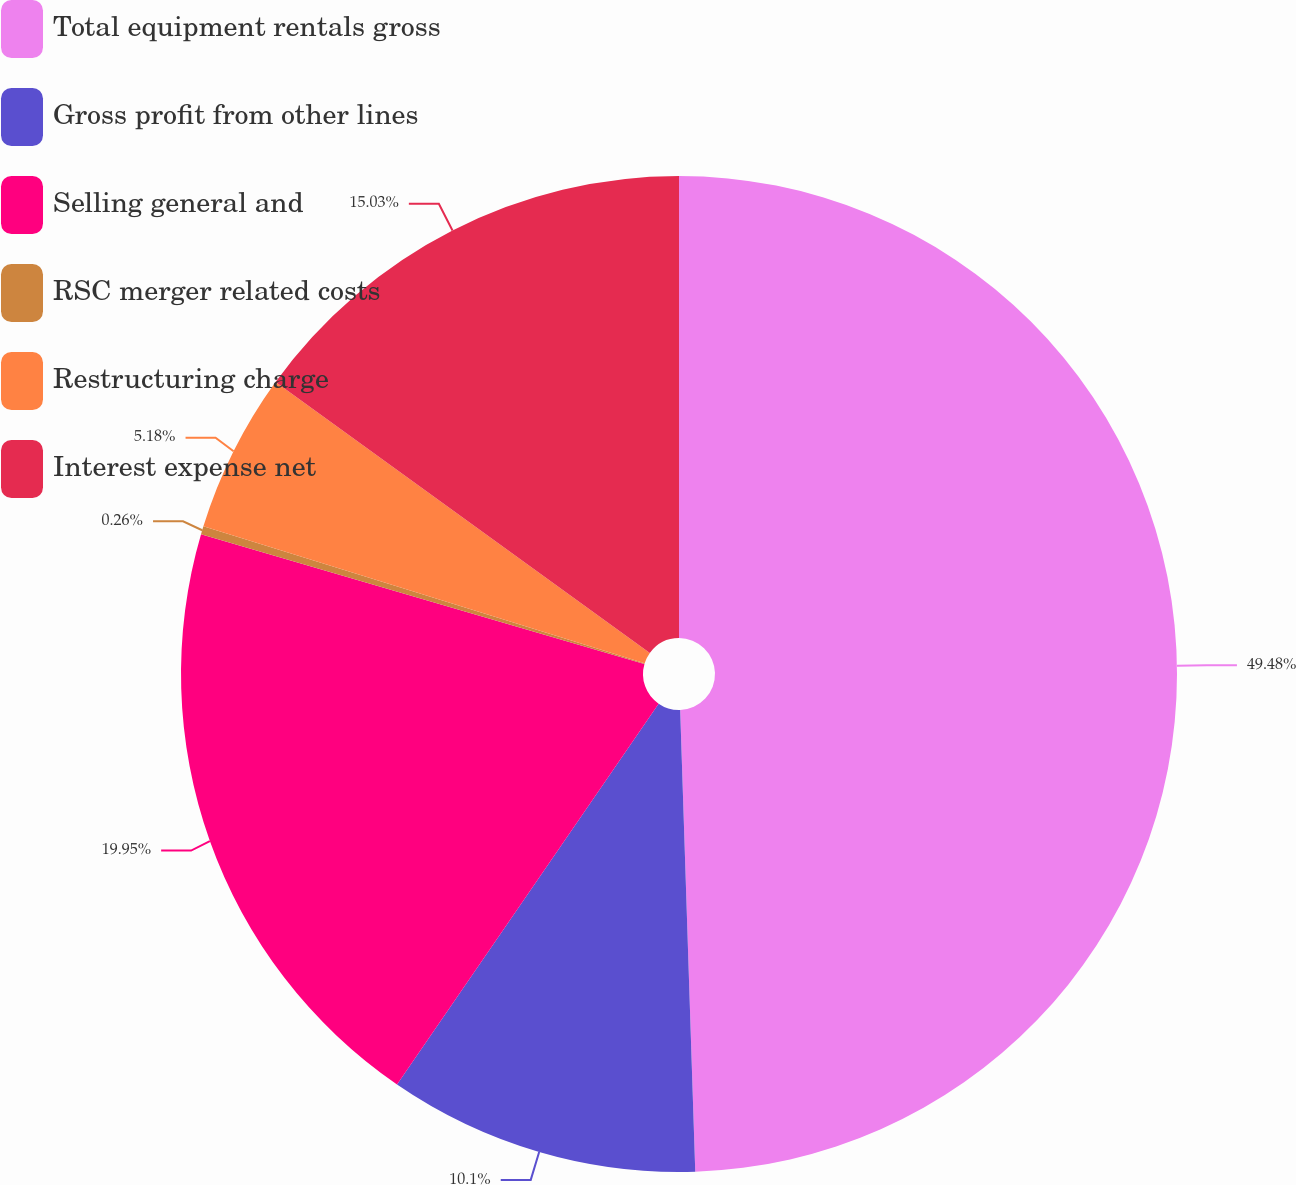Convert chart to OTSL. <chart><loc_0><loc_0><loc_500><loc_500><pie_chart><fcel>Total equipment rentals gross<fcel>Gross profit from other lines<fcel>Selling general and<fcel>RSC merger related costs<fcel>Restructuring charge<fcel>Interest expense net<nl><fcel>49.48%<fcel>10.1%<fcel>19.95%<fcel>0.26%<fcel>5.18%<fcel>15.03%<nl></chart> 